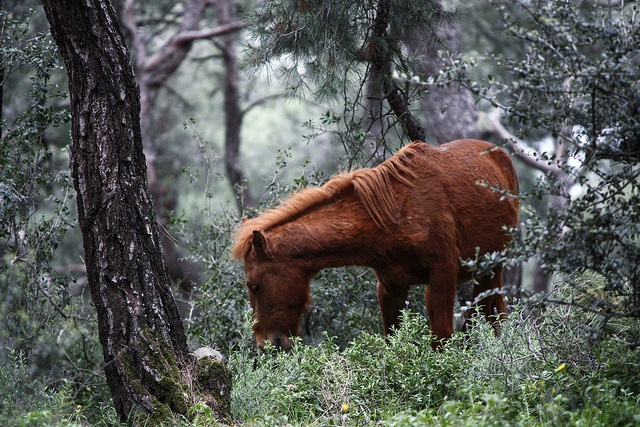Describe the objects in this image and their specific colors. I can see a horse in black, maroon, and brown tones in this image. 